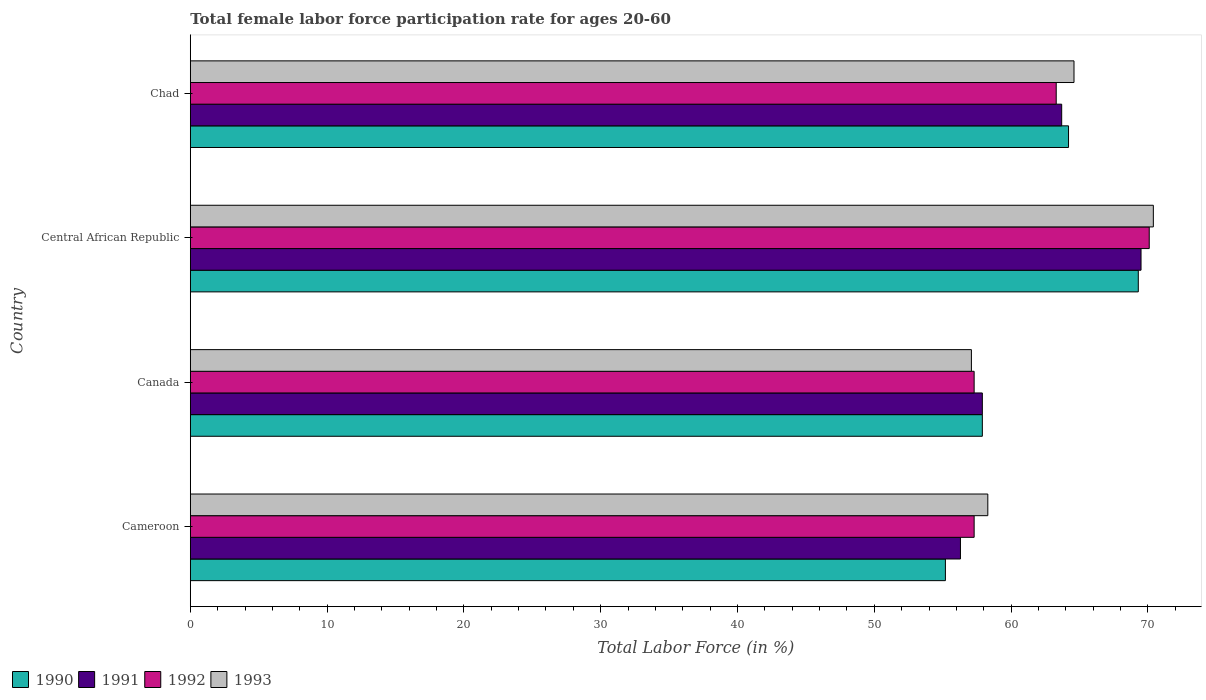Are the number of bars per tick equal to the number of legend labels?
Make the answer very short. Yes. Are the number of bars on each tick of the Y-axis equal?
Offer a very short reply. Yes. How many bars are there on the 2nd tick from the bottom?
Offer a terse response. 4. What is the label of the 4th group of bars from the top?
Your answer should be very brief. Cameroon. What is the female labor force participation rate in 1993 in Chad?
Your response must be concise. 64.6. Across all countries, what is the maximum female labor force participation rate in 1993?
Your answer should be compact. 70.4. Across all countries, what is the minimum female labor force participation rate in 1991?
Keep it short and to the point. 56.3. In which country was the female labor force participation rate in 1993 maximum?
Provide a succinct answer. Central African Republic. In which country was the female labor force participation rate in 1990 minimum?
Make the answer very short. Cameroon. What is the total female labor force participation rate in 1993 in the graph?
Give a very brief answer. 250.4. What is the difference between the female labor force participation rate in 1993 in Cameroon and that in Chad?
Make the answer very short. -6.3. What is the difference between the female labor force participation rate in 1990 in Chad and the female labor force participation rate in 1992 in Cameroon?
Your response must be concise. 6.9. What is the average female labor force participation rate in 1992 per country?
Provide a succinct answer. 62. What is the difference between the female labor force participation rate in 1990 and female labor force participation rate in 1992 in Cameroon?
Offer a very short reply. -2.1. What is the ratio of the female labor force participation rate in 1992 in Cameroon to that in Chad?
Ensure brevity in your answer.  0.91. What is the difference between the highest and the second highest female labor force participation rate in 1992?
Offer a terse response. 6.8. What is the difference between the highest and the lowest female labor force participation rate in 1993?
Your answer should be very brief. 13.3. What does the 4th bar from the top in Chad represents?
Make the answer very short. 1990. What does the 4th bar from the bottom in Chad represents?
Your response must be concise. 1993. Is it the case that in every country, the sum of the female labor force participation rate in 1991 and female labor force participation rate in 1993 is greater than the female labor force participation rate in 1990?
Offer a terse response. Yes. How many bars are there?
Your answer should be very brief. 16. Are all the bars in the graph horizontal?
Make the answer very short. Yes. How many countries are there in the graph?
Your response must be concise. 4. What is the difference between two consecutive major ticks on the X-axis?
Make the answer very short. 10. Does the graph contain any zero values?
Make the answer very short. No. How many legend labels are there?
Offer a terse response. 4. How are the legend labels stacked?
Make the answer very short. Horizontal. What is the title of the graph?
Offer a very short reply. Total female labor force participation rate for ages 20-60. What is the label or title of the X-axis?
Provide a short and direct response. Total Labor Force (in %). What is the Total Labor Force (in %) of 1990 in Cameroon?
Provide a short and direct response. 55.2. What is the Total Labor Force (in %) in 1991 in Cameroon?
Your response must be concise. 56.3. What is the Total Labor Force (in %) in 1992 in Cameroon?
Make the answer very short. 57.3. What is the Total Labor Force (in %) of 1993 in Cameroon?
Provide a short and direct response. 58.3. What is the Total Labor Force (in %) of 1990 in Canada?
Provide a short and direct response. 57.9. What is the Total Labor Force (in %) in 1991 in Canada?
Give a very brief answer. 57.9. What is the Total Labor Force (in %) of 1992 in Canada?
Provide a short and direct response. 57.3. What is the Total Labor Force (in %) in 1993 in Canada?
Your answer should be very brief. 57.1. What is the Total Labor Force (in %) of 1990 in Central African Republic?
Your response must be concise. 69.3. What is the Total Labor Force (in %) of 1991 in Central African Republic?
Keep it short and to the point. 69.5. What is the Total Labor Force (in %) of 1992 in Central African Republic?
Offer a terse response. 70.1. What is the Total Labor Force (in %) in 1993 in Central African Republic?
Provide a short and direct response. 70.4. What is the Total Labor Force (in %) of 1990 in Chad?
Offer a very short reply. 64.2. What is the Total Labor Force (in %) in 1991 in Chad?
Ensure brevity in your answer.  63.7. What is the Total Labor Force (in %) of 1992 in Chad?
Your response must be concise. 63.3. What is the Total Labor Force (in %) of 1993 in Chad?
Your answer should be compact. 64.6. Across all countries, what is the maximum Total Labor Force (in %) of 1990?
Your answer should be compact. 69.3. Across all countries, what is the maximum Total Labor Force (in %) in 1991?
Make the answer very short. 69.5. Across all countries, what is the maximum Total Labor Force (in %) in 1992?
Make the answer very short. 70.1. Across all countries, what is the maximum Total Labor Force (in %) of 1993?
Your answer should be very brief. 70.4. Across all countries, what is the minimum Total Labor Force (in %) in 1990?
Give a very brief answer. 55.2. Across all countries, what is the minimum Total Labor Force (in %) in 1991?
Your answer should be compact. 56.3. Across all countries, what is the minimum Total Labor Force (in %) in 1992?
Provide a short and direct response. 57.3. Across all countries, what is the minimum Total Labor Force (in %) of 1993?
Provide a short and direct response. 57.1. What is the total Total Labor Force (in %) in 1990 in the graph?
Your answer should be very brief. 246.6. What is the total Total Labor Force (in %) of 1991 in the graph?
Your answer should be very brief. 247.4. What is the total Total Labor Force (in %) in 1992 in the graph?
Keep it short and to the point. 248. What is the total Total Labor Force (in %) of 1993 in the graph?
Provide a succinct answer. 250.4. What is the difference between the Total Labor Force (in %) of 1990 in Cameroon and that in Canada?
Make the answer very short. -2.7. What is the difference between the Total Labor Force (in %) of 1993 in Cameroon and that in Canada?
Your response must be concise. 1.2. What is the difference between the Total Labor Force (in %) of 1990 in Cameroon and that in Central African Republic?
Give a very brief answer. -14.1. What is the difference between the Total Labor Force (in %) in 1991 in Cameroon and that in Central African Republic?
Keep it short and to the point. -13.2. What is the difference between the Total Labor Force (in %) in 1993 in Cameroon and that in Central African Republic?
Offer a terse response. -12.1. What is the difference between the Total Labor Force (in %) in 1990 in Cameroon and that in Chad?
Ensure brevity in your answer.  -9. What is the difference between the Total Labor Force (in %) of 1991 in Cameroon and that in Chad?
Keep it short and to the point. -7.4. What is the difference between the Total Labor Force (in %) in 1990 in Canada and that in Central African Republic?
Your answer should be very brief. -11.4. What is the difference between the Total Labor Force (in %) in 1993 in Canada and that in Central African Republic?
Ensure brevity in your answer.  -13.3. What is the difference between the Total Labor Force (in %) of 1990 in Canada and that in Chad?
Your answer should be very brief. -6.3. What is the difference between the Total Labor Force (in %) of 1991 in Canada and that in Chad?
Your response must be concise. -5.8. What is the difference between the Total Labor Force (in %) in 1992 in Canada and that in Chad?
Your response must be concise. -6. What is the difference between the Total Labor Force (in %) in 1993 in Canada and that in Chad?
Make the answer very short. -7.5. What is the difference between the Total Labor Force (in %) of 1991 in Central African Republic and that in Chad?
Your answer should be compact. 5.8. What is the difference between the Total Labor Force (in %) of 1993 in Central African Republic and that in Chad?
Ensure brevity in your answer.  5.8. What is the difference between the Total Labor Force (in %) in 1990 in Cameroon and the Total Labor Force (in %) in 1991 in Canada?
Ensure brevity in your answer.  -2.7. What is the difference between the Total Labor Force (in %) of 1990 in Cameroon and the Total Labor Force (in %) of 1992 in Canada?
Provide a succinct answer. -2.1. What is the difference between the Total Labor Force (in %) of 1990 in Cameroon and the Total Labor Force (in %) of 1993 in Canada?
Your answer should be compact. -1.9. What is the difference between the Total Labor Force (in %) in 1991 in Cameroon and the Total Labor Force (in %) in 1993 in Canada?
Keep it short and to the point. -0.8. What is the difference between the Total Labor Force (in %) in 1990 in Cameroon and the Total Labor Force (in %) in 1991 in Central African Republic?
Offer a very short reply. -14.3. What is the difference between the Total Labor Force (in %) of 1990 in Cameroon and the Total Labor Force (in %) of 1992 in Central African Republic?
Give a very brief answer. -14.9. What is the difference between the Total Labor Force (in %) of 1990 in Cameroon and the Total Labor Force (in %) of 1993 in Central African Republic?
Ensure brevity in your answer.  -15.2. What is the difference between the Total Labor Force (in %) of 1991 in Cameroon and the Total Labor Force (in %) of 1992 in Central African Republic?
Your response must be concise. -13.8. What is the difference between the Total Labor Force (in %) in 1991 in Cameroon and the Total Labor Force (in %) in 1993 in Central African Republic?
Provide a short and direct response. -14.1. What is the difference between the Total Labor Force (in %) in 1992 in Cameroon and the Total Labor Force (in %) in 1993 in Chad?
Your response must be concise. -7.3. What is the difference between the Total Labor Force (in %) in 1990 in Canada and the Total Labor Force (in %) in 1992 in Central African Republic?
Give a very brief answer. -12.2. What is the difference between the Total Labor Force (in %) in 1991 in Canada and the Total Labor Force (in %) in 1992 in Central African Republic?
Provide a succinct answer. -12.2. What is the difference between the Total Labor Force (in %) in 1991 in Canada and the Total Labor Force (in %) in 1993 in Central African Republic?
Keep it short and to the point. -12.5. What is the difference between the Total Labor Force (in %) in 1990 in Canada and the Total Labor Force (in %) in 1991 in Chad?
Your answer should be very brief. -5.8. What is the difference between the Total Labor Force (in %) of 1990 in Canada and the Total Labor Force (in %) of 1992 in Chad?
Your response must be concise. -5.4. What is the difference between the Total Labor Force (in %) of 1990 in Canada and the Total Labor Force (in %) of 1993 in Chad?
Provide a short and direct response. -6.7. What is the difference between the Total Labor Force (in %) of 1991 in Canada and the Total Labor Force (in %) of 1993 in Chad?
Your response must be concise. -6.7. What is the difference between the Total Labor Force (in %) in 1990 in Central African Republic and the Total Labor Force (in %) in 1992 in Chad?
Your answer should be compact. 6. What is the difference between the Total Labor Force (in %) in 1991 in Central African Republic and the Total Labor Force (in %) in 1993 in Chad?
Your response must be concise. 4.9. What is the average Total Labor Force (in %) of 1990 per country?
Offer a terse response. 61.65. What is the average Total Labor Force (in %) of 1991 per country?
Your answer should be very brief. 61.85. What is the average Total Labor Force (in %) in 1992 per country?
Your response must be concise. 62. What is the average Total Labor Force (in %) in 1993 per country?
Keep it short and to the point. 62.6. What is the difference between the Total Labor Force (in %) in 1990 and Total Labor Force (in %) in 1991 in Cameroon?
Offer a terse response. -1.1. What is the difference between the Total Labor Force (in %) in 1991 and Total Labor Force (in %) in 1992 in Cameroon?
Provide a succinct answer. -1. What is the difference between the Total Labor Force (in %) in 1991 and Total Labor Force (in %) in 1993 in Cameroon?
Give a very brief answer. -2. What is the difference between the Total Labor Force (in %) in 1992 and Total Labor Force (in %) in 1993 in Cameroon?
Keep it short and to the point. -1. What is the difference between the Total Labor Force (in %) of 1991 and Total Labor Force (in %) of 1992 in Canada?
Provide a succinct answer. 0.6. What is the difference between the Total Labor Force (in %) of 1991 and Total Labor Force (in %) of 1993 in Canada?
Make the answer very short. 0.8. What is the difference between the Total Labor Force (in %) in 1990 and Total Labor Force (in %) in 1991 in Central African Republic?
Make the answer very short. -0.2. What is the difference between the Total Labor Force (in %) of 1990 and Total Labor Force (in %) of 1993 in Central African Republic?
Offer a very short reply. -1.1. What is the difference between the Total Labor Force (in %) of 1991 and Total Labor Force (in %) of 1992 in Central African Republic?
Make the answer very short. -0.6. What is the difference between the Total Labor Force (in %) of 1991 and Total Labor Force (in %) of 1993 in Chad?
Give a very brief answer. -0.9. What is the ratio of the Total Labor Force (in %) in 1990 in Cameroon to that in Canada?
Offer a very short reply. 0.95. What is the ratio of the Total Labor Force (in %) in 1991 in Cameroon to that in Canada?
Keep it short and to the point. 0.97. What is the ratio of the Total Labor Force (in %) in 1992 in Cameroon to that in Canada?
Provide a succinct answer. 1. What is the ratio of the Total Labor Force (in %) of 1993 in Cameroon to that in Canada?
Your answer should be very brief. 1.02. What is the ratio of the Total Labor Force (in %) in 1990 in Cameroon to that in Central African Republic?
Make the answer very short. 0.8. What is the ratio of the Total Labor Force (in %) of 1991 in Cameroon to that in Central African Republic?
Provide a short and direct response. 0.81. What is the ratio of the Total Labor Force (in %) in 1992 in Cameroon to that in Central African Republic?
Your answer should be compact. 0.82. What is the ratio of the Total Labor Force (in %) in 1993 in Cameroon to that in Central African Republic?
Keep it short and to the point. 0.83. What is the ratio of the Total Labor Force (in %) in 1990 in Cameroon to that in Chad?
Offer a terse response. 0.86. What is the ratio of the Total Labor Force (in %) of 1991 in Cameroon to that in Chad?
Provide a short and direct response. 0.88. What is the ratio of the Total Labor Force (in %) in 1992 in Cameroon to that in Chad?
Provide a short and direct response. 0.91. What is the ratio of the Total Labor Force (in %) in 1993 in Cameroon to that in Chad?
Your response must be concise. 0.9. What is the ratio of the Total Labor Force (in %) in 1990 in Canada to that in Central African Republic?
Your answer should be very brief. 0.84. What is the ratio of the Total Labor Force (in %) of 1991 in Canada to that in Central African Republic?
Provide a succinct answer. 0.83. What is the ratio of the Total Labor Force (in %) in 1992 in Canada to that in Central African Republic?
Make the answer very short. 0.82. What is the ratio of the Total Labor Force (in %) of 1993 in Canada to that in Central African Republic?
Offer a very short reply. 0.81. What is the ratio of the Total Labor Force (in %) of 1990 in Canada to that in Chad?
Keep it short and to the point. 0.9. What is the ratio of the Total Labor Force (in %) of 1991 in Canada to that in Chad?
Give a very brief answer. 0.91. What is the ratio of the Total Labor Force (in %) of 1992 in Canada to that in Chad?
Keep it short and to the point. 0.91. What is the ratio of the Total Labor Force (in %) in 1993 in Canada to that in Chad?
Offer a terse response. 0.88. What is the ratio of the Total Labor Force (in %) in 1990 in Central African Republic to that in Chad?
Make the answer very short. 1.08. What is the ratio of the Total Labor Force (in %) in 1991 in Central African Republic to that in Chad?
Your answer should be very brief. 1.09. What is the ratio of the Total Labor Force (in %) in 1992 in Central African Republic to that in Chad?
Your answer should be compact. 1.11. What is the ratio of the Total Labor Force (in %) of 1993 in Central African Republic to that in Chad?
Provide a short and direct response. 1.09. What is the difference between the highest and the second highest Total Labor Force (in %) in 1990?
Ensure brevity in your answer.  5.1. What is the difference between the highest and the second highest Total Labor Force (in %) in 1991?
Your response must be concise. 5.8. What is the difference between the highest and the second highest Total Labor Force (in %) in 1992?
Keep it short and to the point. 6.8. What is the difference between the highest and the lowest Total Labor Force (in %) in 1990?
Ensure brevity in your answer.  14.1. What is the difference between the highest and the lowest Total Labor Force (in %) of 1991?
Your answer should be very brief. 13.2. What is the difference between the highest and the lowest Total Labor Force (in %) of 1993?
Ensure brevity in your answer.  13.3. 